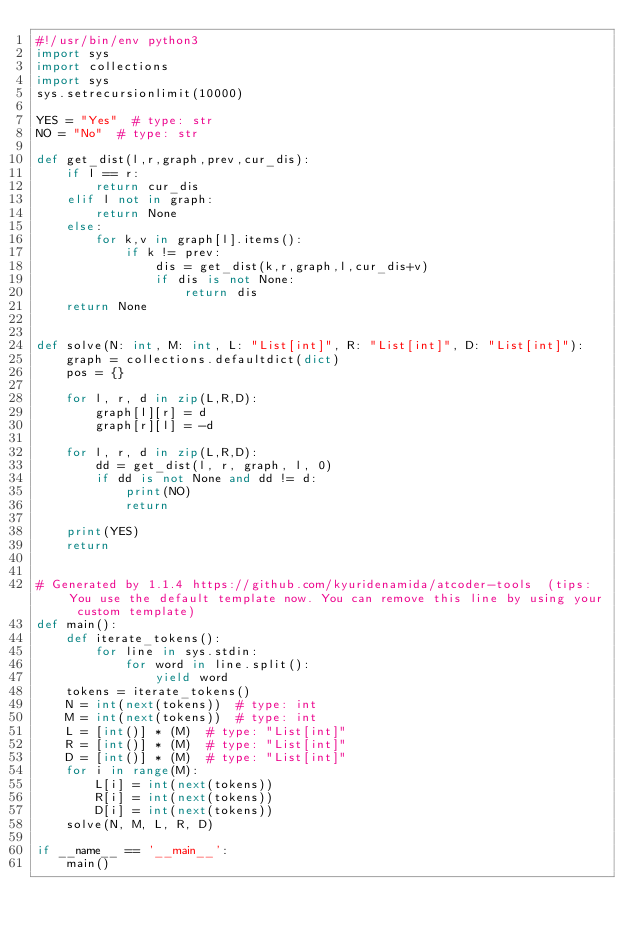<code> <loc_0><loc_0><loc_500><loc_500><_Python_>#!/usr/bin/env python3
import sys
import collections
import sys
sys.setrecursionlimit(10000)

YES = "Yes"  # type: str
NO = "No"  # type: str

def get_dist(l,r,graph,prev,cur_dis):
    if l == r:
        return cur_dis
    elif l not in graph:
        return None
    else:
        for k,v in graph[l].items():
            if k != prev:
                dis = get_dist(k,r,graph,l,cur_dis+v)
                if dis is not None:
                    return dis
    return None


def solve(N: int, M: int, L: "List[int]", R: "List[int]", D: "List[int]"):
    graph = collections.defaultdict(dict)
    pos = {}

    for l, r, d in zip(L,R,D):
        graph[l][r] = d
        graph[r][l] = -d

    for l, r, d in zip(L,R,D):
        dd = get_dist(l, r, graph, l, 0)
        if dd is not None and dd != d:
            print(NO)
            return

    print(YES)
    return


# Generated by 1.1.4 https://github.com/kyuridenamida/atcoder-tools  (tips: You use the default template now. You can remove this line by using your custom template)
def main():
    def iterate_tokens():
        for line in sys.stdin:
            for word in line.split():
                yield word
    tokens = iterate_tokens()
    N = int(next(tokens))  # type: int
    M = int(next(tokens))  # type: int
    L = [int()] * (M)  # type: "List[int]" 
    R = [int()] * (M)  # type: "List[int]" 
    D = [int()] * (M)  # type: "List[int]" 
    for i in range(M):
        L[i] = int(next(tokens))
        R[i] = int(next(tokens))
        D[i] = int(next(tokens))
    solve(N, M, L, R, D)

if __name__ == '__main__':
    main()
</code> 